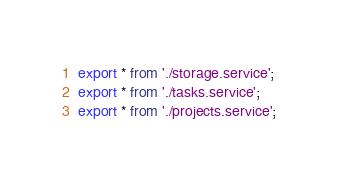<code> <loc_0><loc_0><loc_500><loc_500><_TypeScript_>export * from './storage.service';
export * from './tasks.service';
export * from './projects.service';</code> 